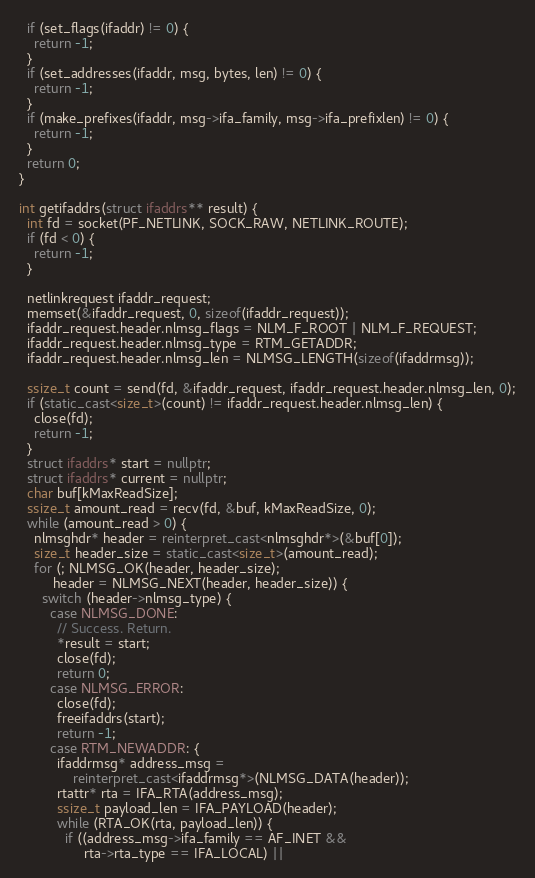Convert code to text. <code><loc_0><loc_0><loc_500><loc_500><_C++_>  if (set_flags(ifaddr) != 0) {
    return -1;
  }
  if (set_addresses(ifaddr, msg, bytes, len) != 0) {
    return -1;
  }
  if (make_prefixes(ifaddr, msg->ifa_family, msg->ifa_prefixlen) != 0) {
    return -1;
  }
  return 0;
}

int getifaddrs(struct ifaddrs** result) {
  int fd = socket(PF_NETLINK, SOCK_RAW, NETLINK_ROUTE);
  if (fd < 0) {
    return -1;
  }

  netlinkrequest ifaddr_request;
  memset(&ifaddr_request, 0, sizeof(ifaddr_request));
  ifaddr_request.header.nlmsg_flags = NLM_F_ROOT | NLM_F_REQUEST;
  ifaddr_request.header.nlmsg_type = RTM_GETADDR;
  ifaddr_request.header.nlmsg_len = NLMSG_LENGTH(sizeof(ifaddrmsg));

  ssize_t count = send(fd, &ifaddr_request, ifaddr_request.header.nlmsg_len, 0);
  if (static_cast<size_t>(count) != ifaddr_request.header.nlmsg_len) {
    close(fd);
    return -1;
  }
  struct ifaddrs* start = nullptr;
  struct ifaddrs* current = nullptr;
  char buf[kMaxReadSize];
  ssize_t amount_read = recv(fd, &buf, kMaxReadSize, 0);
  while (amount_read > 0) {
    nlmsghdr* header = reinterpret_cast<nlmsghdr*>(&buf[0]);
    size_t header_size = static_cast<size_t>(amount_read);
    for (; NLMSG_OK(header, header_size);
         header = NLMSG_NEXT(header, header_size)) {
      switch (header->nlmsg_type) {
        case NLMSG_DONE:
          // Success. Return.
          *result = start;
          close(fd);
          return 0;
        case NLMSG_ERROR:
          close(fd);
          freeifaddrs(start);
          return -1;
        case RTM_NEWADDR: {
          ifaddrmsg* address_msg =
              reinterpret_cast<ifaddrmsg*>(NLMSG_DATA(header));
          rtattr* rta = IFA_RTA(address_msg);
          ssize_t payload_len = IFA_PAYLOAD(header);
          while (RTA_OK(rta, payload_len)) {
            if ((address_msg->ifa_family == AF_INET &&
                 rta->rta_type == IFA_LOCAL) ||</code> 